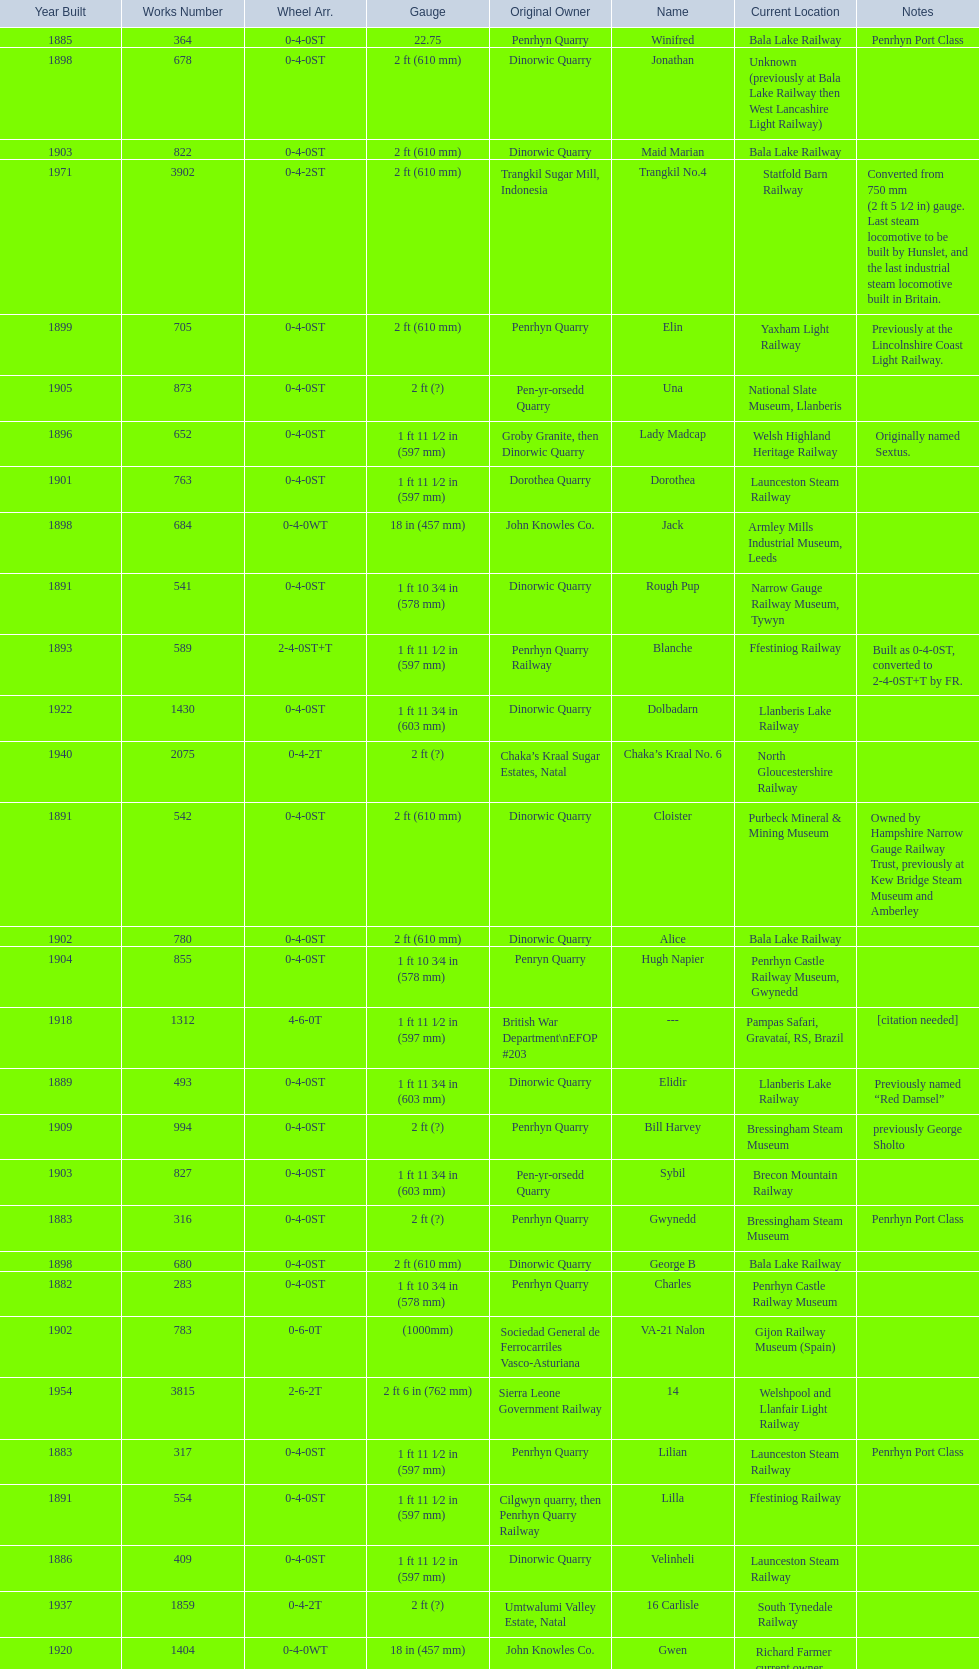What is the difference in gauge between works numbers 541 and 542? 32 mm. 